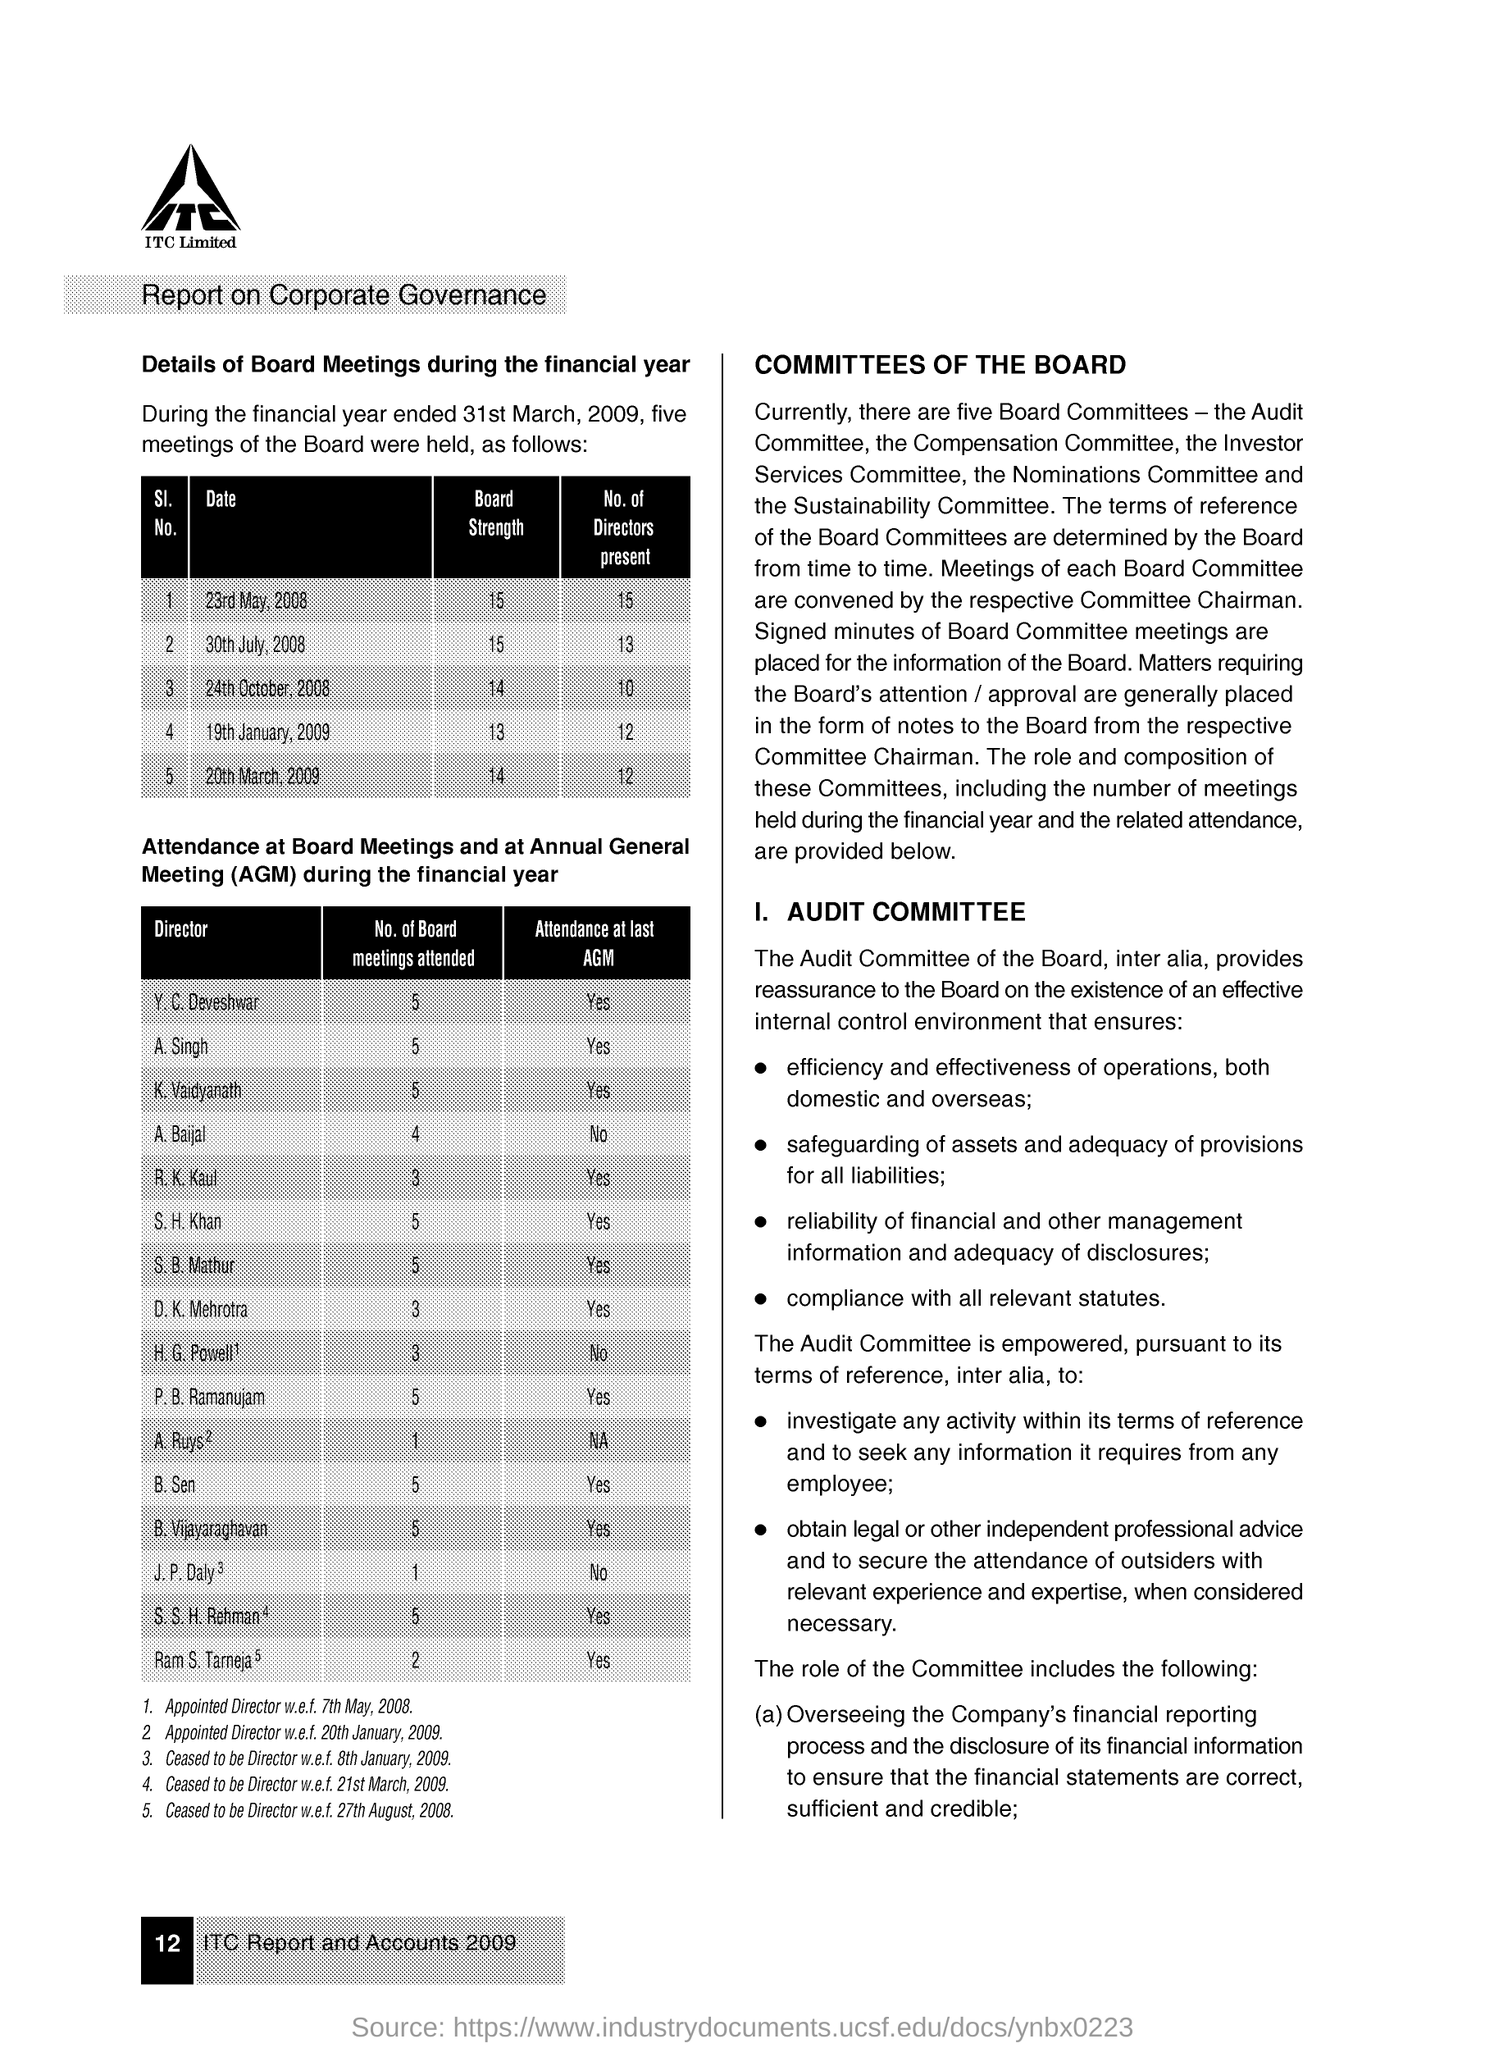During the financial year ended 31st march, 2009,how many board meetings were held?
Your answer should be compact. Five. On 19th january, 2009 how many no of directors were present?
Give a very brief answer. 12. 